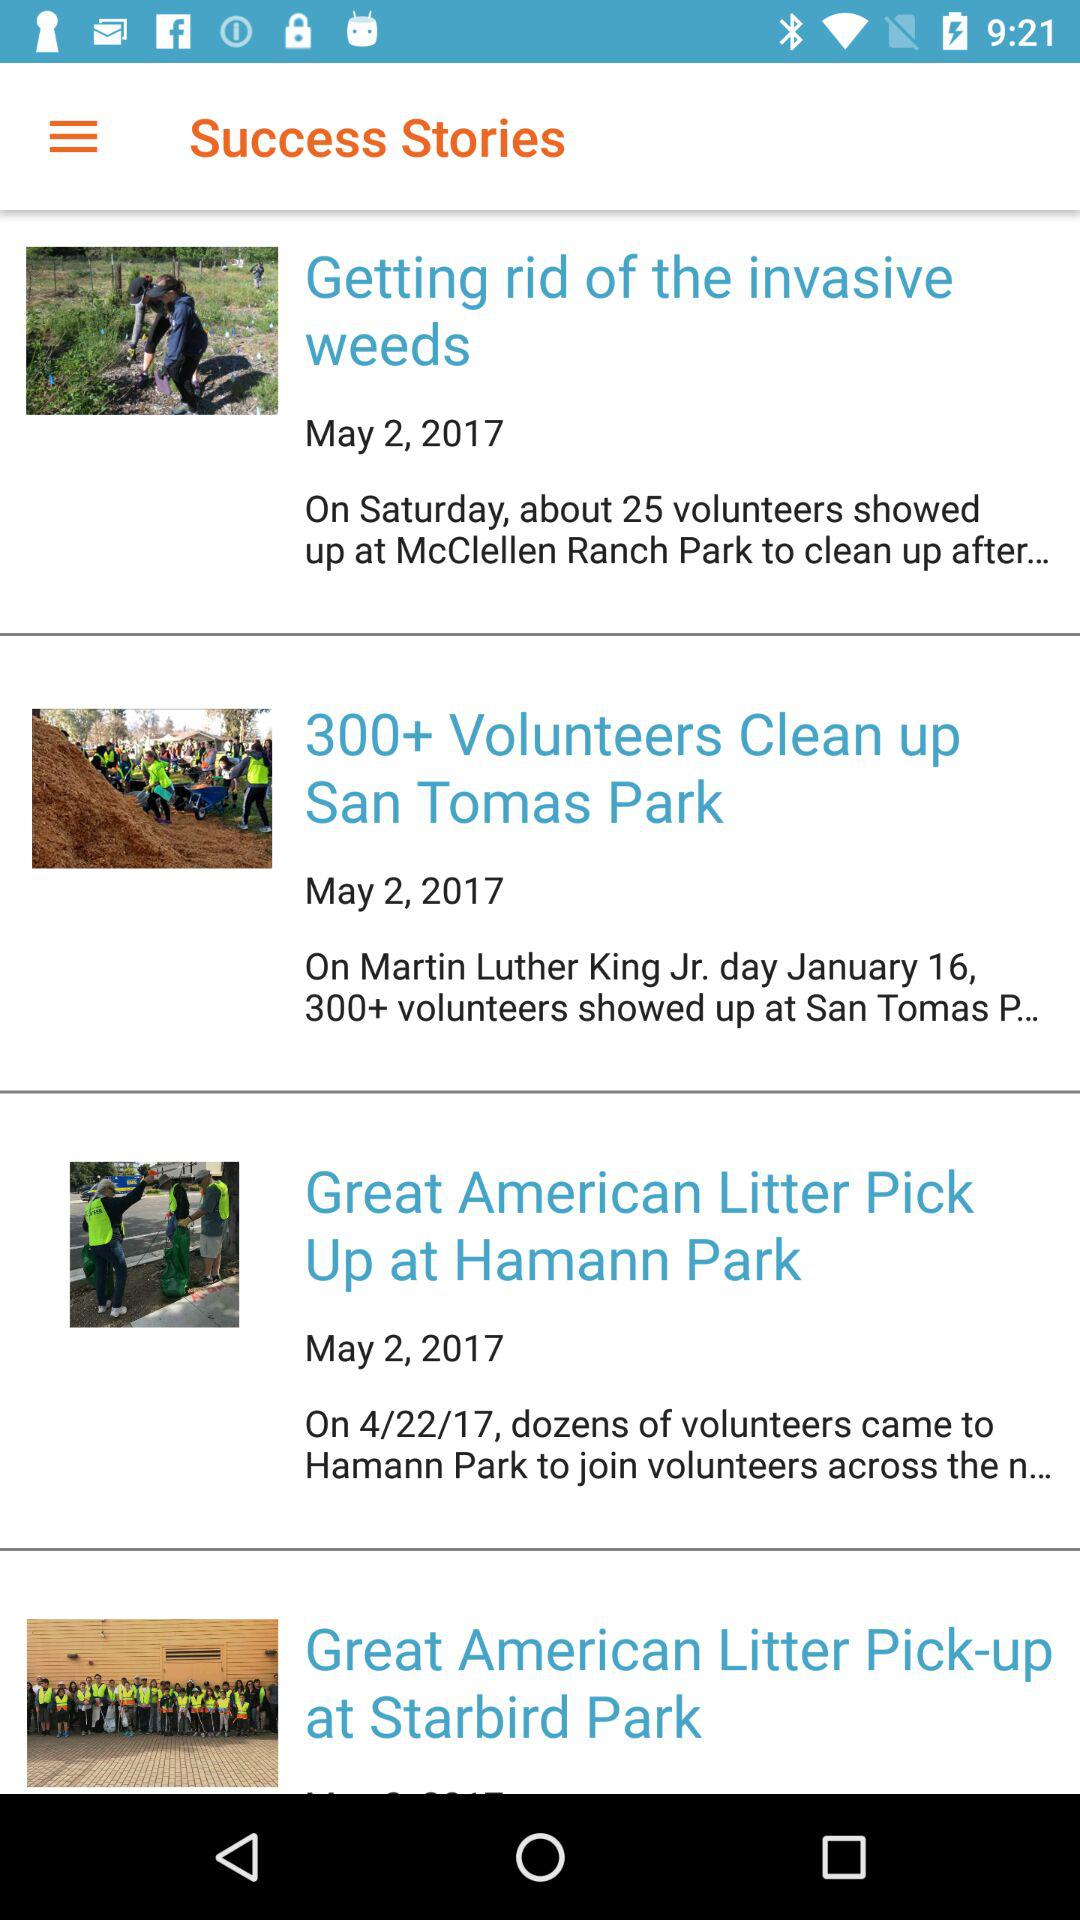What is the time for 300+ volunteers to clean up San Tomas Park?
When the provided information is insufficient, respond with <no answer>. <no answer> 